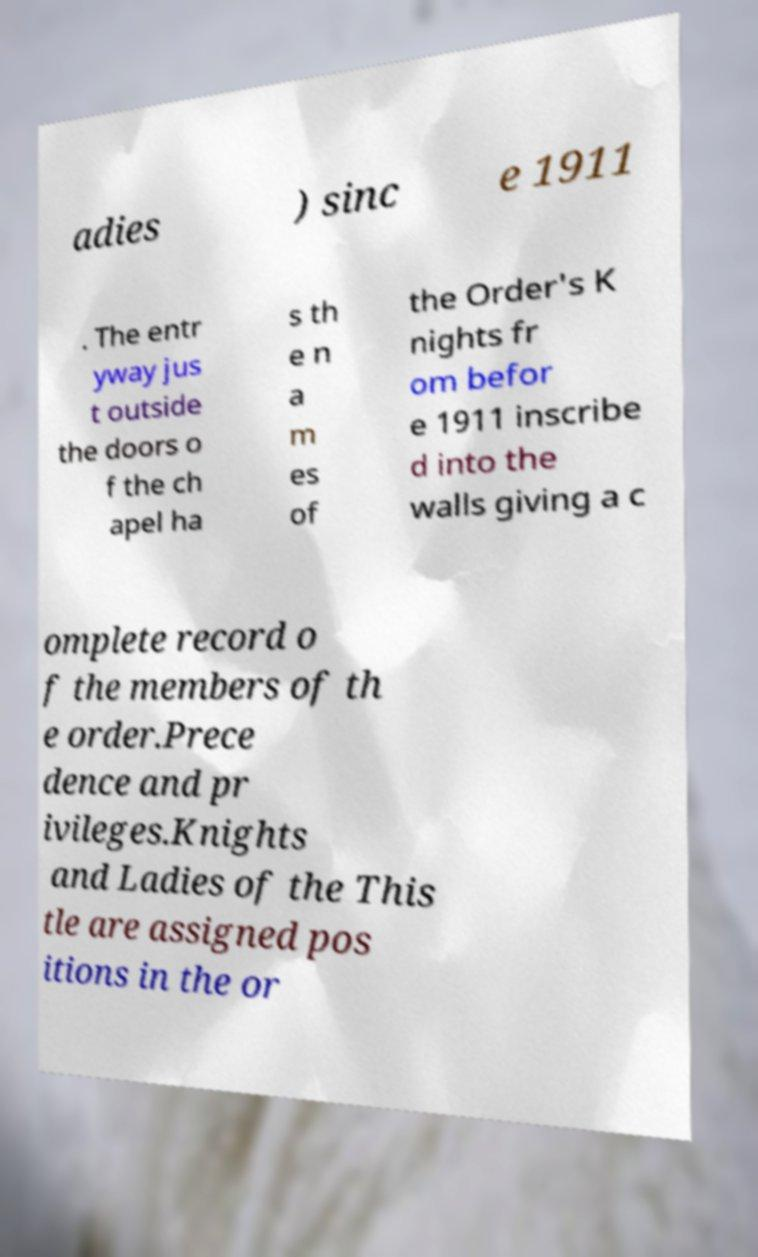Can you accurately transcribe the text from the provided image for me? adies ) sinc e 1911 . The entr yway jus t outside the doors o f the ch apel ha s th e n a m es of the Order's K nights fr om befor e 1911 inscribe d into the walls giving a c omplete record o f the members of th e order.Prece dence and pr ivileges.Knights and Ladies of the This tle are assigned pos itions in the or 